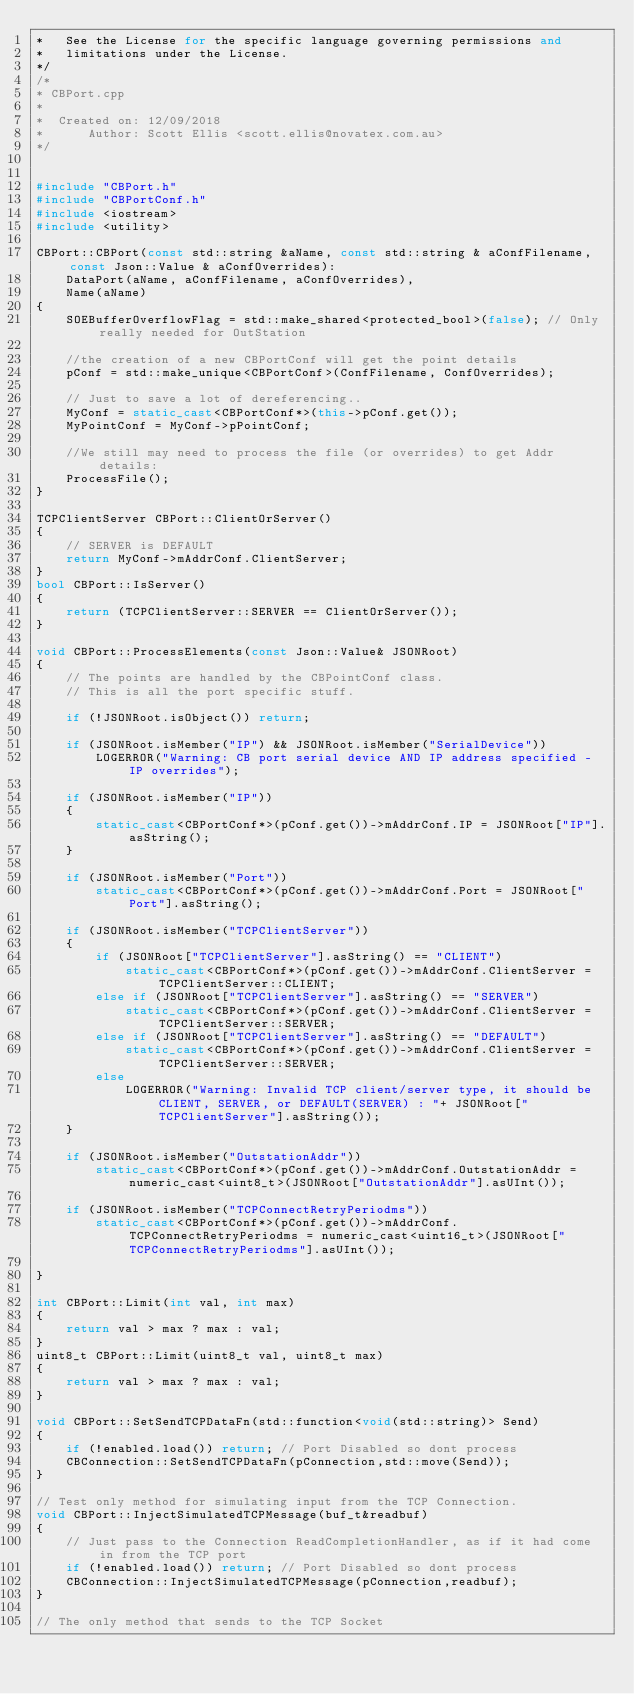Convert code to text. <code><loc_0><loc_0><loc_500><loc_500><_C++_>*	See the License for the specific language governing permissions and
*	limitations under the License.
*/
/*
* CBPort.cpp
*
*  Created on: 12/09/2018
*      Author: Scott Ellis <scott.ellis@novatex.com.au>
*/


#include "CBPort.h"
#include "CBPortConf.h"
#include <iostream>
#include <utility>

CBPort::CBPort(const std::string &aName, const std::string & aConfFilename, const Json::Value & aConfOverrides):
	DataPort(aName, aConfFilename, aConfOverrides),
	Name(aName)
{
	SOEBufferOverflowFlag = std::make_shared<protected_bool>(false); // Only really needed for OutStation

	//the creation of a new CBPortConf will get the point details
	pConf = std::make_unique<CBPortConf>(ConfFilename, ConfOverrides);

	// Just to save a lot of dereferencing..
	MyConf = static_cast<CBPortConf*>(this->pConf.get());
	MyPointConf = MyConf->pPointConf;

	//We still may need to process the file (or overrides) to get Addr details:
	ProcessFile();
}

TCPClientServer CBPort::ClientOrServer()
{
	// SERVER is DEFAULT
	return MyConf->mAddrConf.ClientServer;
}
bool CBPort::IsServer()
{
	return (TCPClientServer::SERVER == ClientOrServer());
}

void CBPort::ProcessElements(const Json::Value& JSONRoot)
{
	// The points are handled by the CBPointConf class.
	// This is all the port specific stuff.

	if (!JSONRoot.isObject()) return;

	if (JSONRoot.isMember("IP") && JSONRoot.isMember("SerialDevice"))
		LOGERROR("Warning: CB port serial device AND IP address specified - IP overrides");

	if (JSONRoot.isMember("IP"))
	{
		static_cast<CBPortConf*>(pConf.get())->mAddrConf.IP = JSONRoot["IP"].asString();
	}

	if (JSONRoot.isMember("Port"))
		static_cast<CBPortConf*>(pConf.get())->mAddrConf.Port = JSONRoot["Port"].asString();

	if (JSONRoot.isMember("TCPClientServer"))
	{
		if (JSONRoot["TCPClientServer"].asString() == "CLIENT")
			static_cast<CBPortConf*>(pConf.get())->mAddrConf.ClientServer = TCPClientServer::CLIENT;
		else if (JSONRoot["TCPClientServer"].asString() == "SERVER")
			static_cast<CBPortConf*>(pConf.get())->mAddrConf.ClientServer = TCPClientServer::SERVER;
		else if (JSONRoot["TCPClientServer"].asString() == "DEFAULT")
			static_cast<CBPortConf*>(pConf.get())->mAddrConf.ClientServer = TCPClientServer::SERVER;
		else
			LOGERROR("Warning: Invalid TCP client/server type, it should be CLIENT, SERVER, or DEFAULT(SERVER) : "+ JSONRoot["TCPClientServer"].asString());
	}

	if (JSONRoot.isMember("OutstationAddr"))
		static_cast<CBPortConf*>(pConf.get())->mAddrConf.OutstationAddr = numeric_cast<uint8_t>(JSONRoot["OutstationAddr"].asUInt());

	if (JSONRoot.isMember("TCPConnectRetryPeriodms"))
		static_cast<CBPortConf*>(pConf.get())->mAddrConf.TCPConnectRetryPeriodms = numeric_cast<uint16_t>(JSONRoot["TCPConnectRetryPeriodms"].asUInt());

}

int CBPort::Limit(int val, int max)
{
	return val > max ? max : val;
}
uint8_t CBPort::Limit(uint8_t val, uint8_t max)
{
	return val > max ? max : val;
}

void CBPort::SetSendTCPDataFn(std::function<void(std::string)> Send)
{
	if (!enabled.load()) return; // Port Disabled so dont process
	CBConnection::SetSendTCPDataFn(pConnection,std::move(Send));
}

// Test only method for simulating input from the TCP Connection.
void CBPort::InjectSimulatedTCPMessage(buf_t&readbuf)
{
	// Just pass to the Connection ReadCompletionHandler, as if it had come in from the TCP port
	if (!enabled.load()) return; // Port Disabled so dont process
	CBConnection::InjectSimulatedTCPMessage(pConnection,readbuf);
}

// The only method that sends to the TCP Socket</code> 